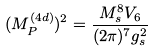Convert formula to latex. <formula><loc_0><loc_0><loc_500><loc_500>( M _ { P } ^ { ( 4 d ) } ) ^ { 2 } = \frac { M _ { s } ^ { 8 } V _ { 6 } } { ( 2 \pi ) ^ { 7 } g _ { s } ^ { 2 } }</formula> 